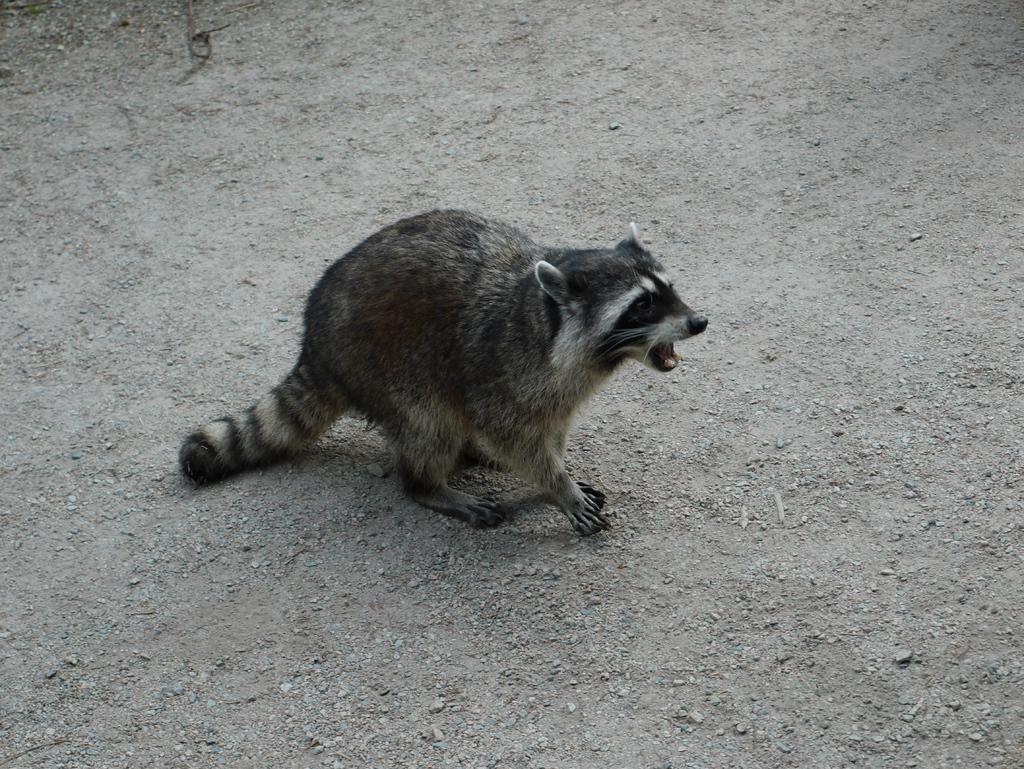In one or two sentences, can you explain what this image depicts? In this image I can see an animal on the ground. 